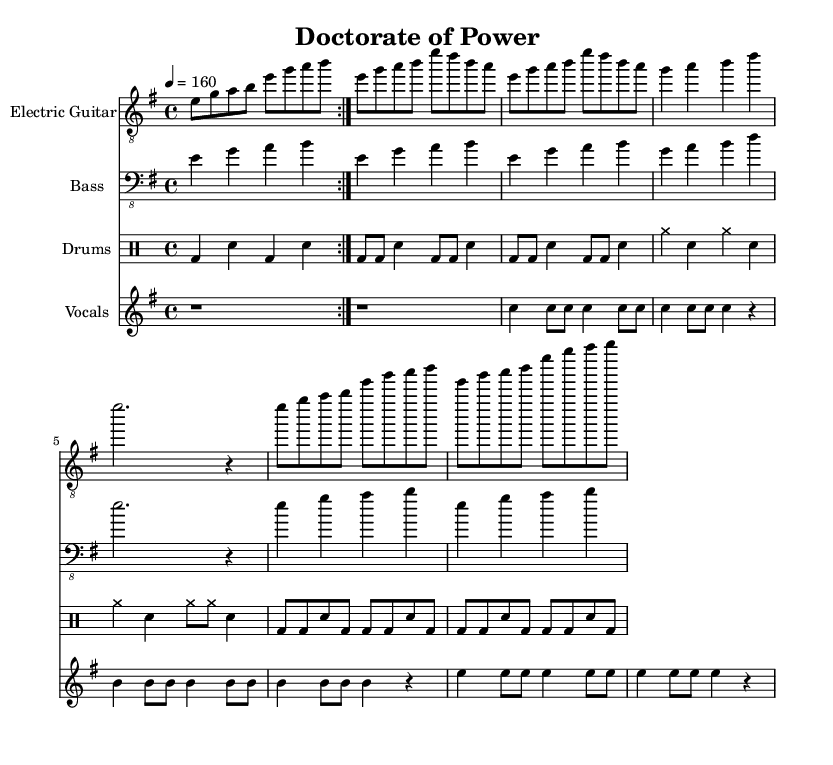What is the key signature of this music? The key signature is E minor, indicated by one sharp, which is F#. This can be seen in the beginning of the sheet music before the time signature.
Answer: E minor What is the time signature of the piece? The time signature is 4/4, meaning there are four beats in each measure. This is shown right after the key signature at the start of the music.
Answer: 4/4 What is the tempo marking for the music? The tempo marking is 160 beats per minute, denoted by "4 = 160" in the tempo section of the global settings. This indicates how fast the piece should be played.
Answer: 160 How many sections does the song have? The song has four distinct sections: Intro, Verse, Pre-Chorus, and Chorus. Each section is marked clearly within the score, creating a structured layout.
Answer: Four What is the primary instrument for this piece? The primary instrument for this song is the Electric Guitar, as indicated at the beginning of the corresponding staff. The electric guitar carries the main melody throughout the piece.
Answer: Electric Guitar What lyrical theme is present in the chorus? The lyrical theme present in the chorus celebrates academic achievement, emphasizing the "Doctorate of Power" and "scholarly tower" as symbols of success. This is evident in the text provided under the vocal part.
Answer: Academic achievement What musical elements identify this piece as a power metal anthem? The piece features fast tempo, heavy electric guitar riffs, a driving bass line, and empowering lyrics, which are characteristic elements of power metal anthems. These are conveyed through the aggressive rhythm and uplifting themes in the score.
Answer: Fast tempo, heavy riffs, empowering lyrics 